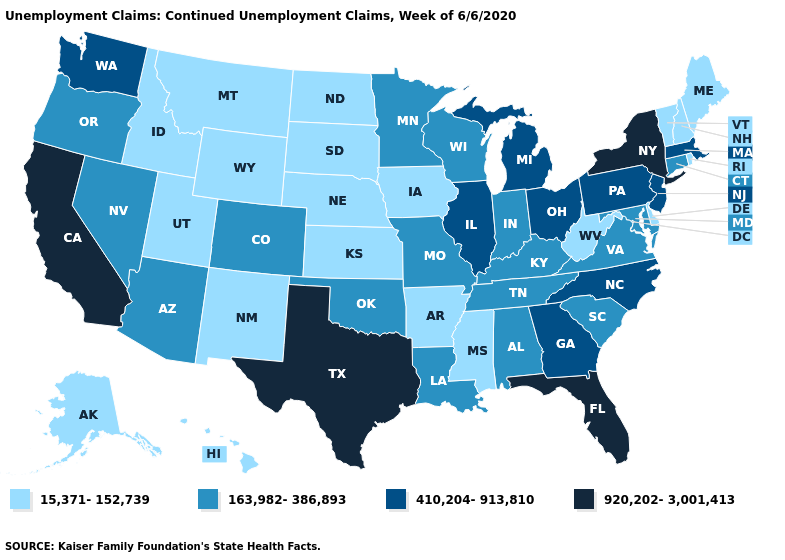Does the first symbol in the legend represent the smallest category?
Keep it brief. Yes. Among the states that border Arizona , does Colorado have the highest value?
Keep it brief. No. What is the value of Hawaii?
Short answer required. 15,371-152,739. What is the value of Vermont?
Give a very brief answer. 15,371-152,739. Name the states that have a value in the range 163,982-386,893?
Short answer required. Alabama, Arizona, Colorado, Connecticut, Indiana, Kentucky, Louisiana, Maryland, Minnesota, Missouri, Nevada, Oklahoma, Oregon, South Carolina, Tennessee, Virginia, Wisconsin. Among the states that border Arkansas , which have the lowest value?
Concise answer only. Mississippi. Does Arizona have a higher value than Nevada?
Be succinct. No. What is the value of Oklahoma?
Be succinct. 163,982-386,893. What is the value of South Dakota?
Quick response, please. 15,371-152,739. What is the highest value in the Northeast ?
Quick response, please. 920,202-3,001,413. Name the states that have a value in the range 410,204-913,810?
Give a very brief answer. Georgia, Illinois, Massachusetts, Michigan, New Jersey, North Carolina, Ohio, Pennsylvania, Washington. Name the states that have a value in the range 920,202-3,001,413?
Keep it brief. California, Florida, New York, Texas. Name the states that have a value in the range 15,371-152,739?
Answer briefly. Alaska, Arkansas, Delaware, Hawaii, Idaho, Iowa, Kansas, Maine, Mississippi, Montana, Nebraska, New Hampshire, New Mexico, North Dakota, Rhode Island, South Dakota, Utah, Vermont, West Virginia, Wyoming. What is the value of California?
Answer briefly. 920,202-3,001,413. Name the states that have a value in the range 15,371-152,739?
Short answer required. Alaska, Arkansas, Delaware, Hawaii, Idaho, Iowa, Kansas, Maine, Mississippi, Montana, Nebraska, New Hampshire, New Mexico, North Dakota, Rhode Island, South Dakota, Utah, Vermont, West Virginia, Wyoming. 